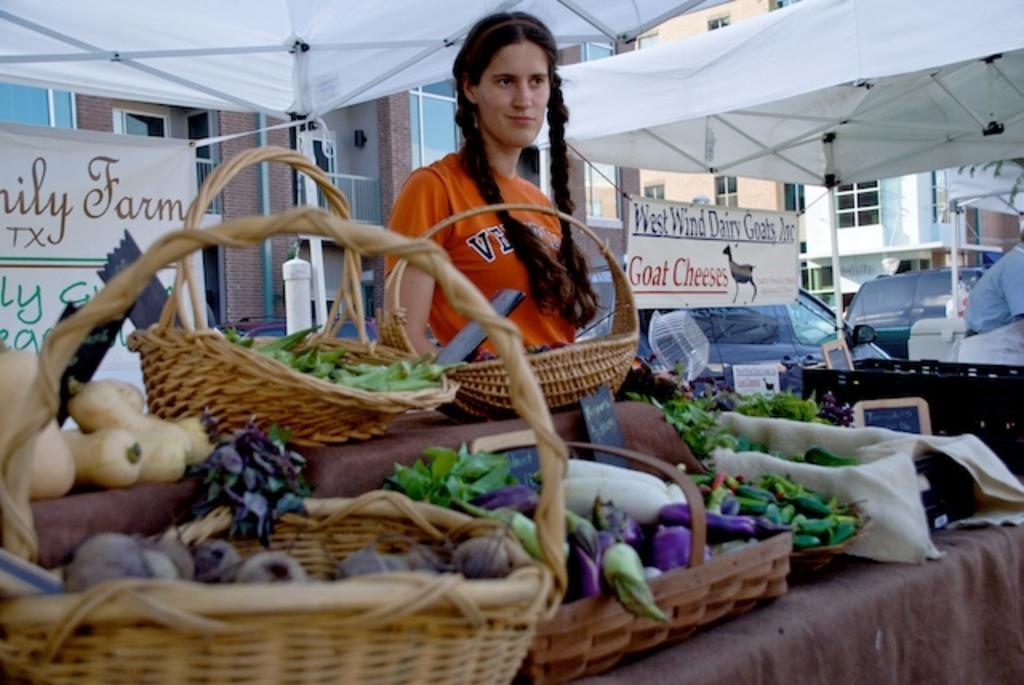Can you describe this image briefly? In this image, we can see a few people. We can see different types of vegetables. There are a few buildings and banners. We can see some vehicles and boards. 